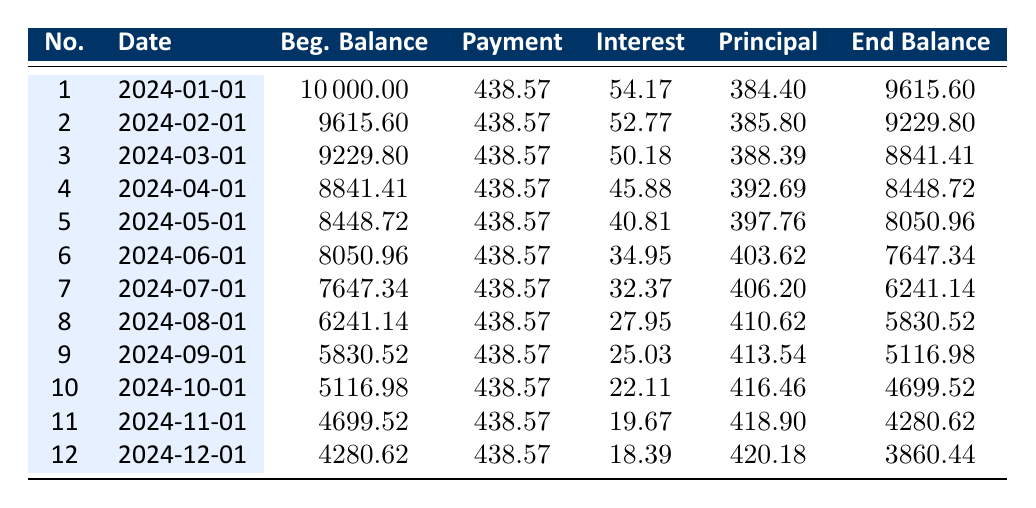What is the interest amount paid in the first month? The interest for the first month is listed under the "Interest" column for payment number 1, which shows 54.17. Therefore, the interest amount paid in the first month is simply the value provided in that cell.
Answer: 54.17 What is the principal repayment amount for the second month? In the "Principal" column for payment number 2, the value is 385.80. This value indicates how much of the loan principal has been repaid in the second month.
Answer: 385.80 How much total interest will be paid over the entire loan term? The total interest paid over the loan term is provided in the loan details section as 1524.17. This indicates the cumulative interest amount that will be paid by the end of the loan term.
Answer: 1524.17 What is the average monthly payment amount? The monthly payment is consistently 438.57 across all months. As there are 24 months in total, the average monthly payment is simply the same value since it does not change.
Answer: 438.57 Is the ending balance after the third payment more than 9000? To find the ending balance after the third payment, we look at the "End Balance" for payment number 3, which is 8841.41. Since 8841.41 is less than 9000, the answer is no.
Answer: No What is the total principal repaid after the first six months? To find the total principal repaid after six months, we sum the "Principal" column values for payments 1 through 6. This gives us: 384.40 + 385.80 + 388.39 + 392.69 + 397.76 + 403.62 = 2292.66.
Answer: 2292.66 How much is the ending balance after the sixth payment? The ending balance after the sixth payment is found in the "End Balance" for payment number 6, which is listed as 7647.34. This is the remaining loan amount after the sixth payment is applied.
Answer: 7647.34 What is the highest principal payment made in any month? The "Principal" amounts across all payments must be compared. The maximum value is found to be 420.18 from the last payment. Thus, it indicates the highest principal repayment in a single month.
Answer: 420.18 Is the payment amount consistent throughout the loan? All monthly payments are listed as 438.57 in every month from payments 1 to 12. Since there are no variations in this value, the answer is yes.
Answer: Yes 